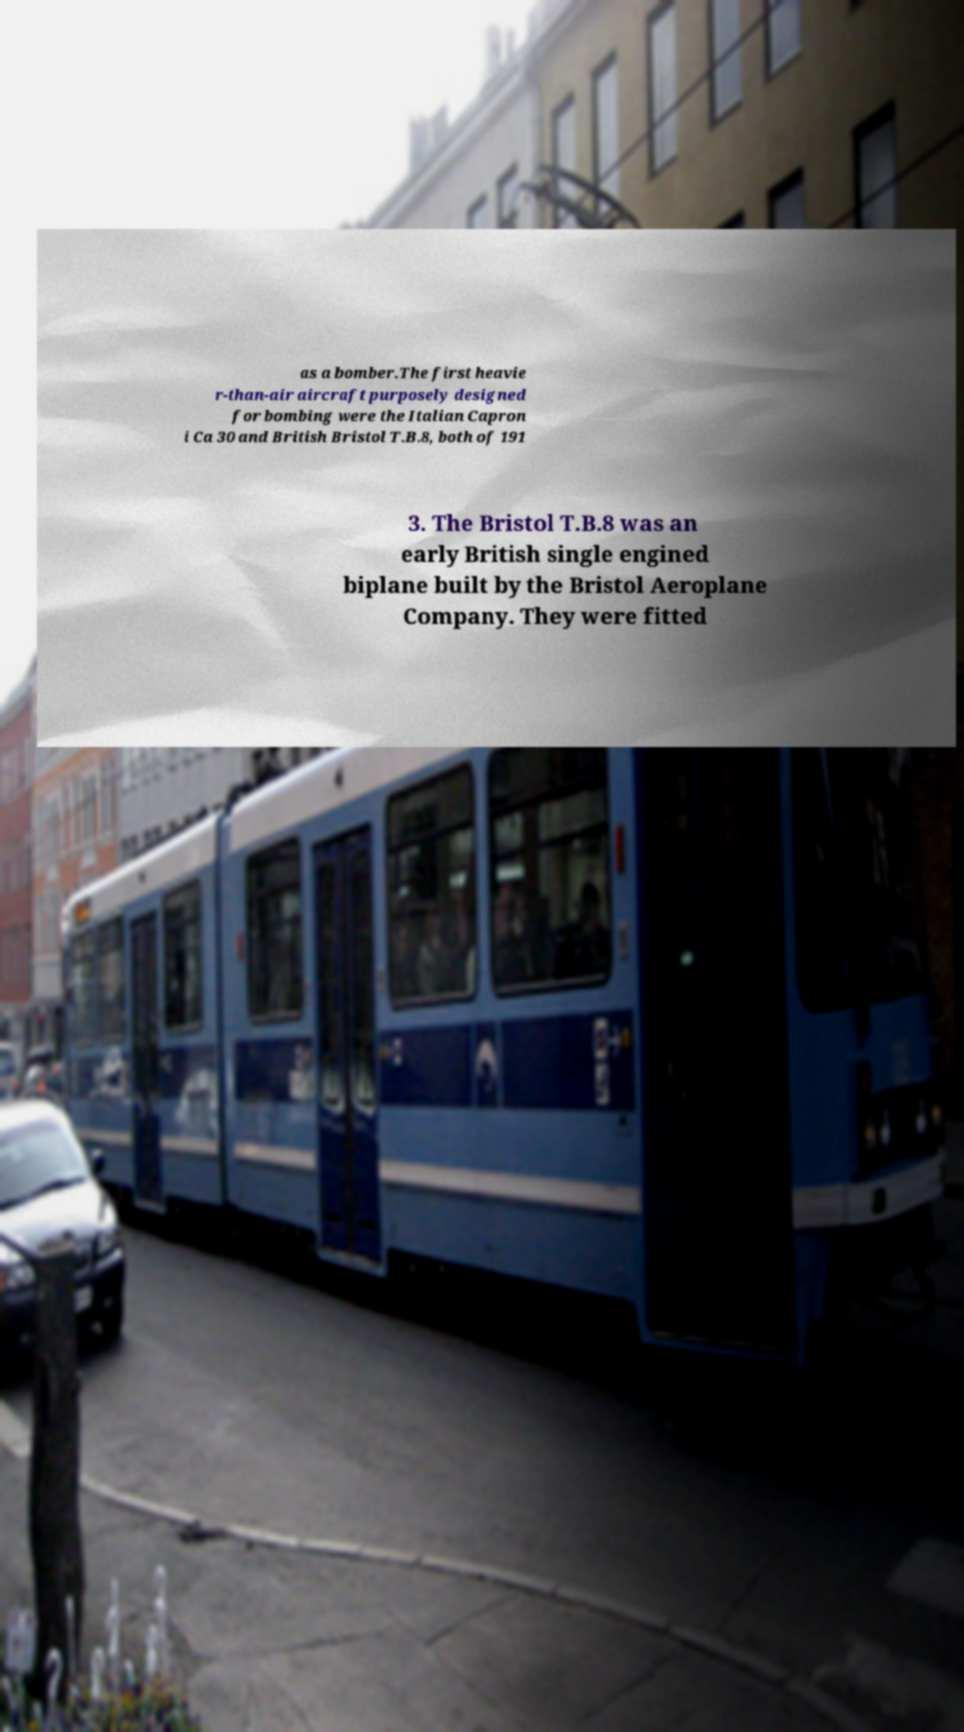Please identify and transcribe the text found in this image. as a bomber.The first heavie r-than-air aircraft purposely designed for bombing were the Italian Capron i Ca 30 and British Bristol T.B.8, both of 191 3. The Bristol T.B.8 was an early British single engined biplane built by the Bristol Aeroplane Company. They were fitted 